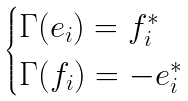<formula> <loc_0><loc_0><loc_500><loc_500>\begin{cases} \Gamma ( e _ { i } ) = f _ { i } ^ { * } & \\ \Gamma ( f _ { i } ) = - e _ { i } ^ { * } \end{cases}</formula> 